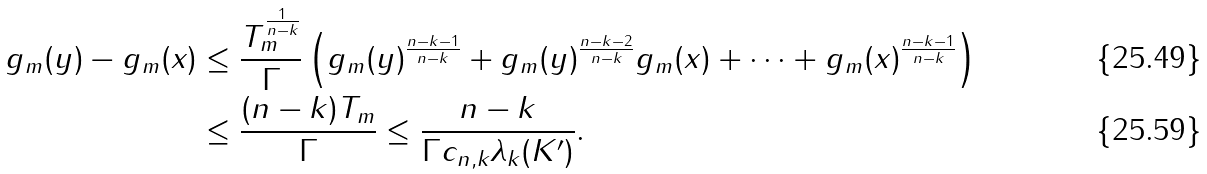<formula> <loc_0><loc_0><loc_500><loc_500>g _ { m } ( y ) - g _ { m } ( x ) & \leq \frac { T _ { m } ^ { \frac { 1 } { n - k } } } { \Gamma } \left ( g _ { m } ( y ) ^ { \frac { n - k - 1 } { n - k } } + g _ { m } ( y ) ^ { \frac { n - k - 2 } { n - k } } g _ { m } ( x ) + \dots + g _ { m } ( x ) ^ { \frac { n - k - 1 } { n - k } } \right ) \\ & \leq \frac { ( n - k ) T _ { m } } { \Gamma } \leq \frac { n - k } { \Gamma c _ { n , k } \lambda _ { k } ( K ^ { \prime } ) } .</formula> 